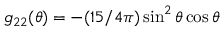Convert formula to latex. <formula><loc_0><loc_0><loc_500><loc_500>g _ { 2 2 } ( \theta ) = - ( 1 5 / 4 \pi ) \sin ^ { 2 } \theta \cos \theta</formula> 